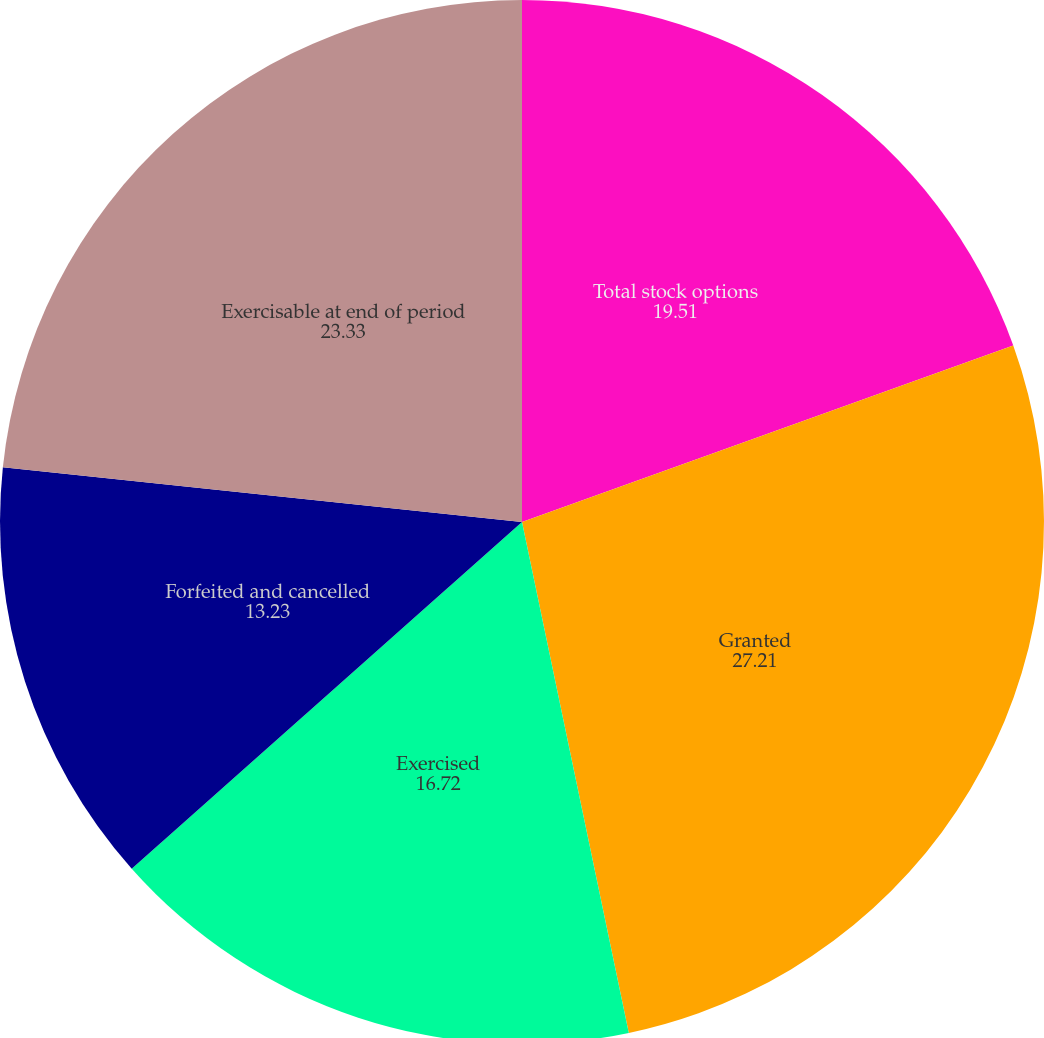Convert chart to OTSL. <chart><loc_0><loc_0><loc_500><loc_500><pie_chart><fcel>Total stock options<fcel>Granted<fcel>Exercised<fcel>Forfeited and cancelled<fcel>Exercisable at end of period<nl><fcel>19.51%<fcel>27.21%<fcel>16.72%<fcel>13.23%<fcel>23.33%<nl></chart> 